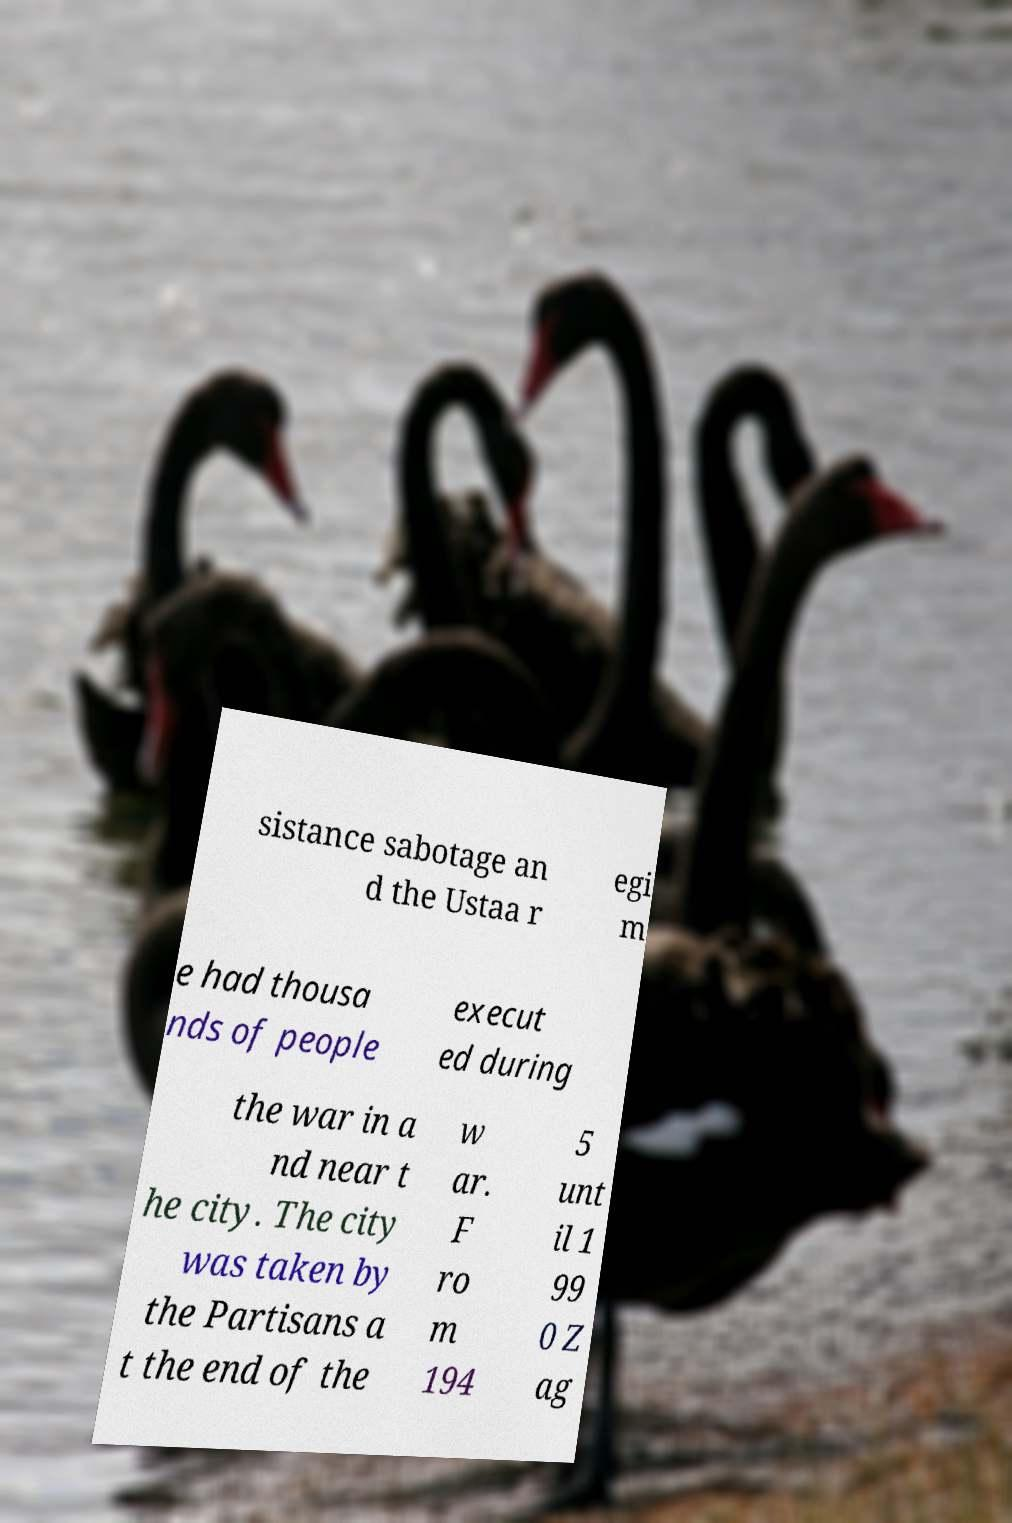Can you accurately transcribe the text from the provided image for me? sistance sabotage an d the Ustaa r egi m e had thousa nds of people execut ed during the war in a nd near t he city. The city was taken by the Partisans a t the end of the w ar. F ro m 194 5 unt il 1 99 0 Z ag 